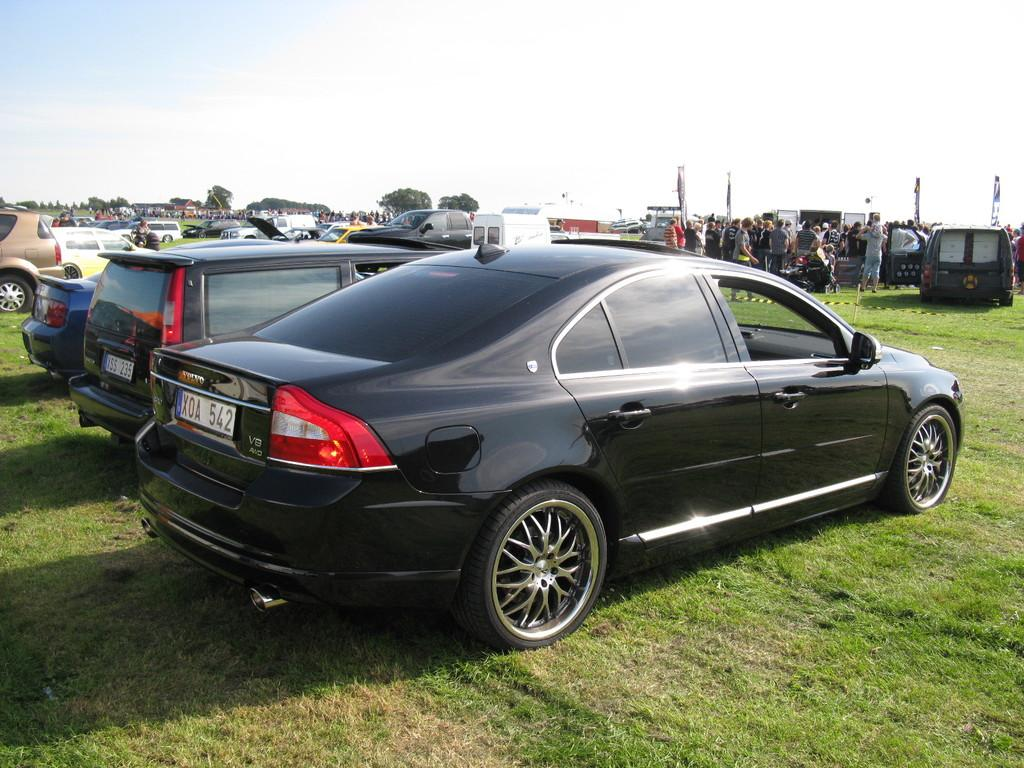What types of objects are present in the image? There are vehicles and people in the image. What can be seen in the background of the image? There are trees in the image. What is the ground covered with in the image? The ground is covered with grass in the image. What is visible at the top of the image? The sky is visible at the top of the image. Where is the sack of potatoes located in the image? There is no sack of potatoes present in the image. What type of machine can be seen operating in the image? There is no machine present in the image. 